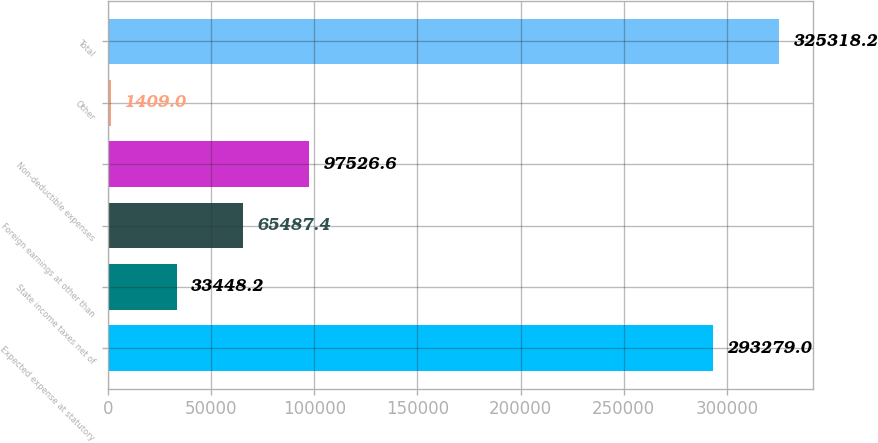<chart> <loc_0><loc_0><loc_500><loc_500><bar_chart><fcel>Expected expense at statutory<fcel>State income taxes net of<fcel>Foreign earnings at other than<fcel>Non-deductible expenses<fcel>Other<fcel>Total<nl><fcel>293279<fcel>33448.2<fcel>65487.4<fcel>97526.6<fcel>1409<fcel>325318<nl></chart> 